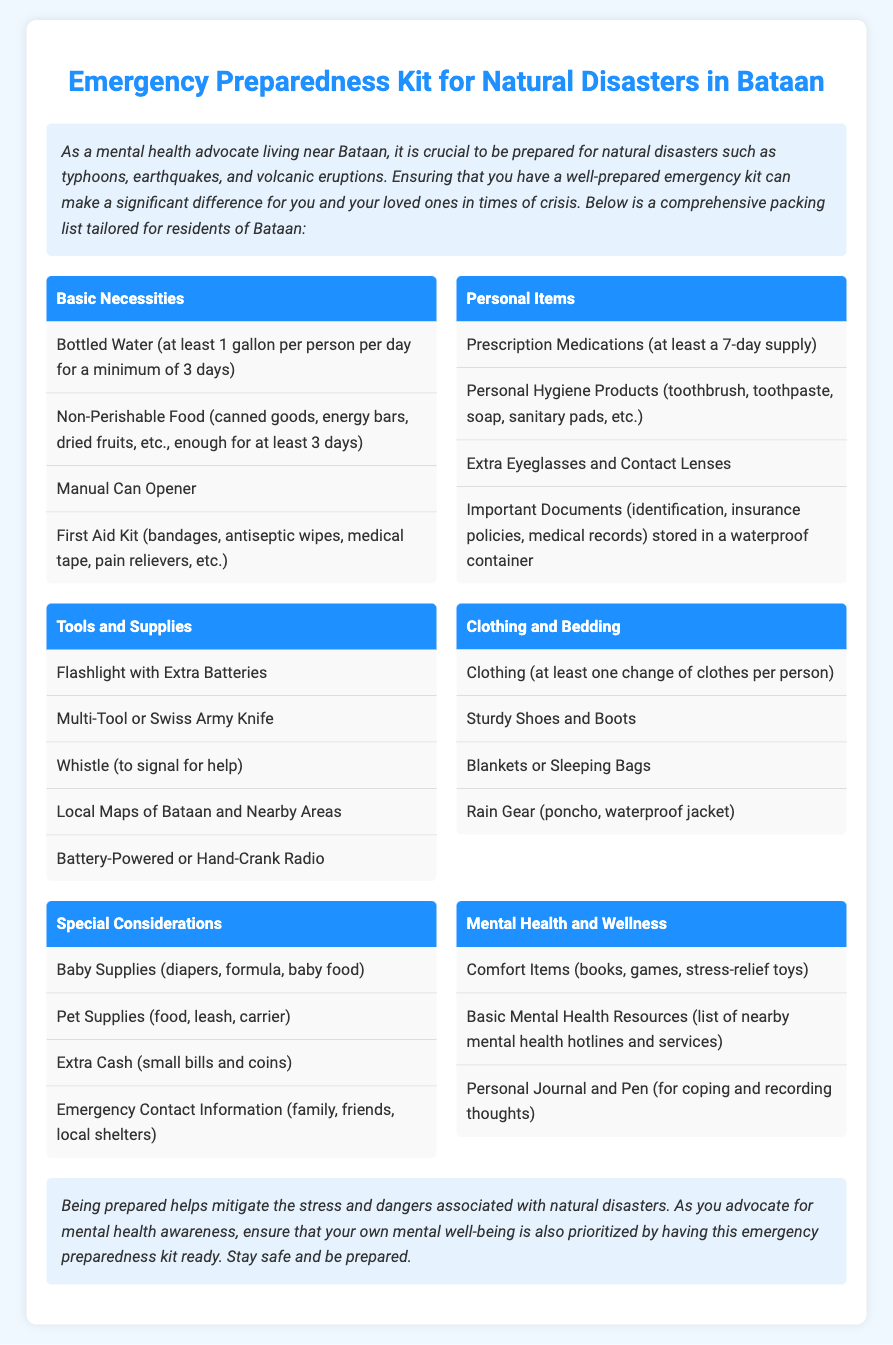What is the recommended amount of bottled water? The document states that at least 1 gallon per person per day for a minimum of 3 days is recommended.
Answer: 1 gallon per person per day for a minimum of 3 days How many categories are there in the packing list? The document lists six categories for the emergency preparedness kit.
Answer: Six What should be used to store important documents? The document mentions that important documents should be stored in a waterproof container.
Answer: Waterproof container What item can be used to signal for help? According to the document, a whistle can be used to signal for help.
Answer: Whistle What are comfort items suggested for mental health? The document lists books, games, and stress-relief toys as comfort items for mental health.
Answer: Books, games, stress-relief toys Which category includes baby supplies? The category that mentions baby supplies is Special Considerations.
Answer: Special Considerations What type of food is recommended for the emergency kit? Non-perishable food, such as canned goods and energy bars, is recommended for the kit.
Answer: Non-Perishable Food What does the conclusion emphasize about being prepared? The conclusion states that being prepared helps mitigate the stress and dangers associated with natural disasters.
Answer: Mitigate stress and dangers 